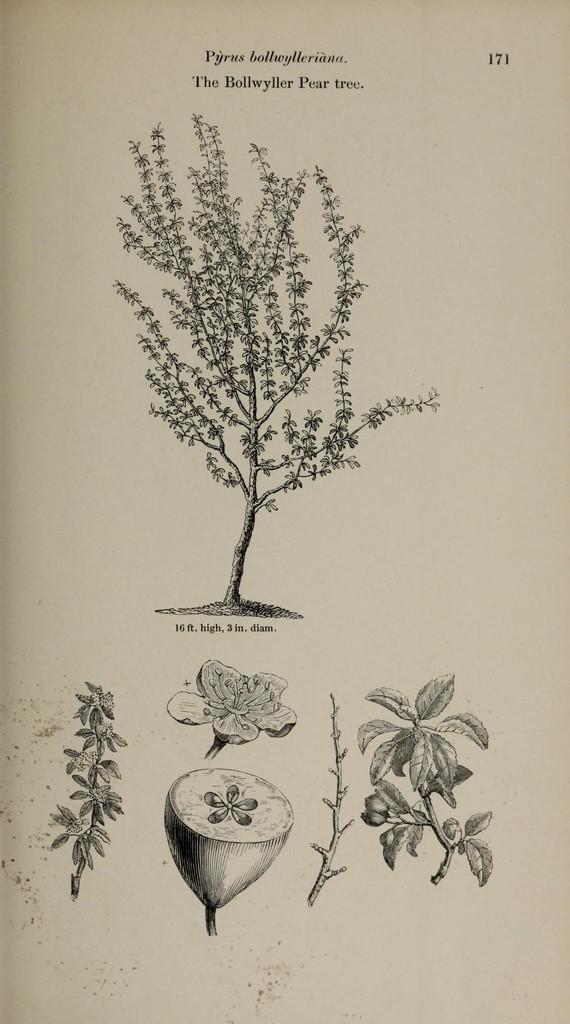In one or two sentences, can you explain what this image depicts? In this picture there is a page, which contains parts of a plant. 